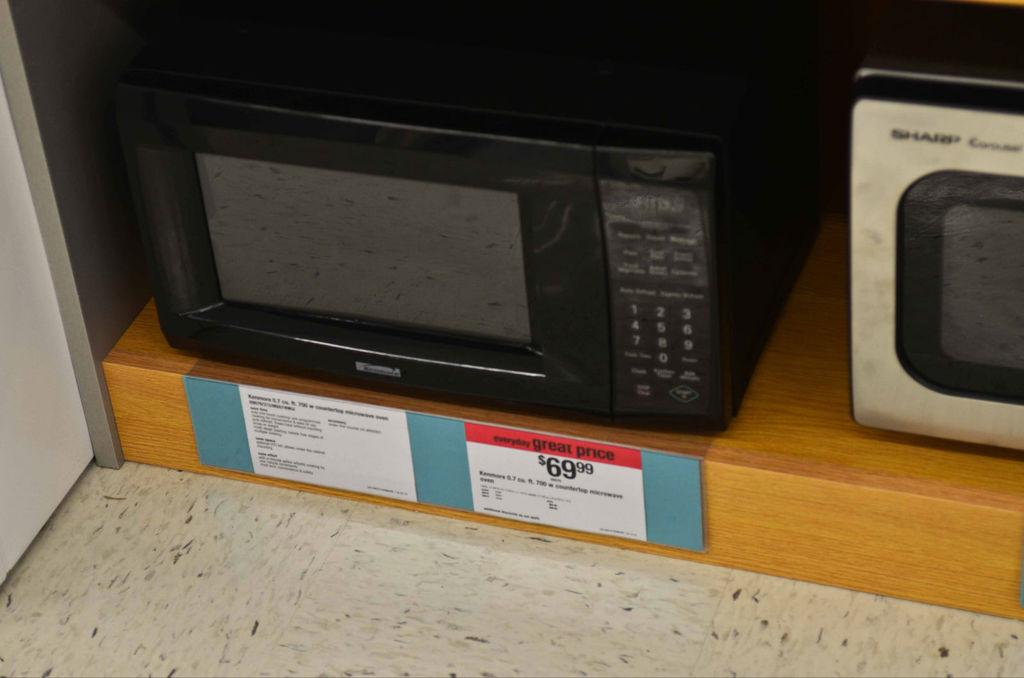<image>
Render a clear and concise summary of the photo. old black colored  microwave oven placed in a rack with the price listing $6999 